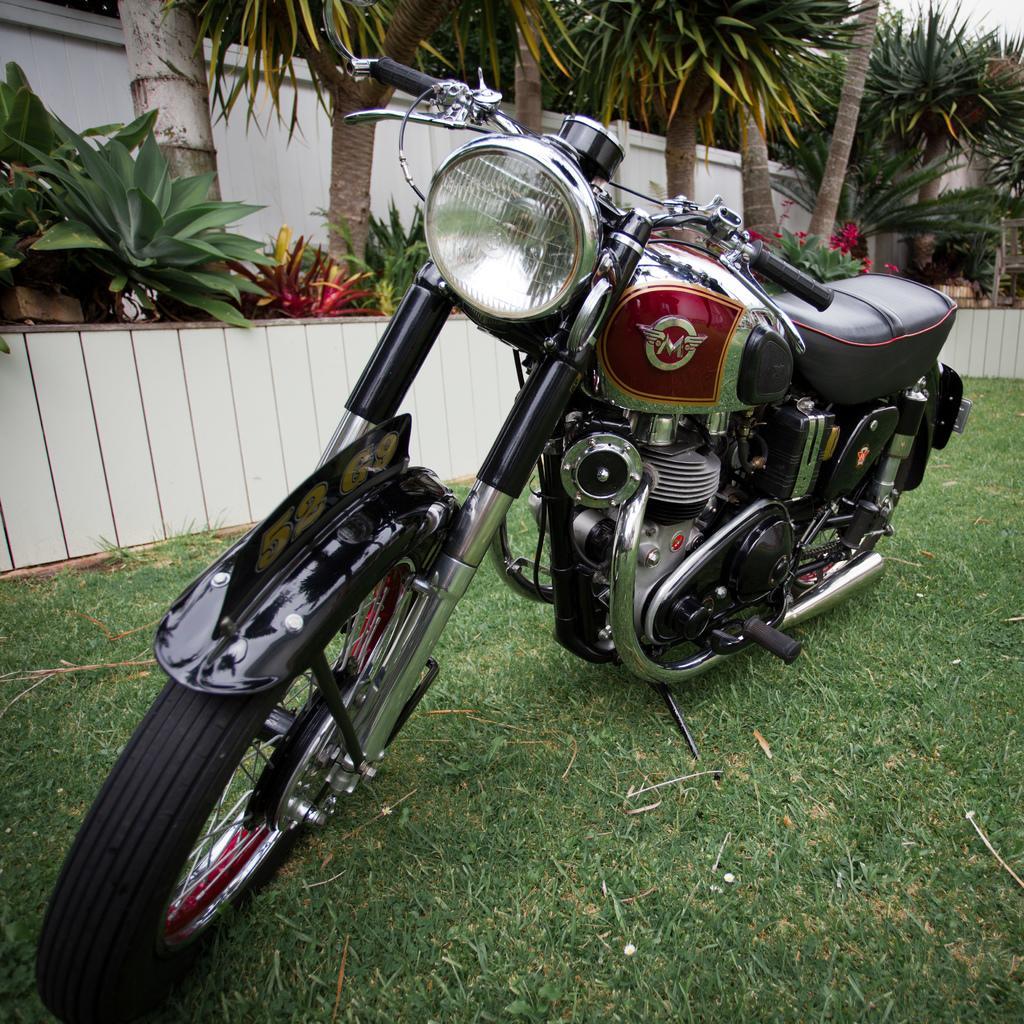Please provide a concise description of this image. In the picture we can see the bike is parked on the grass surface beside it, we can see some plants and trees. 